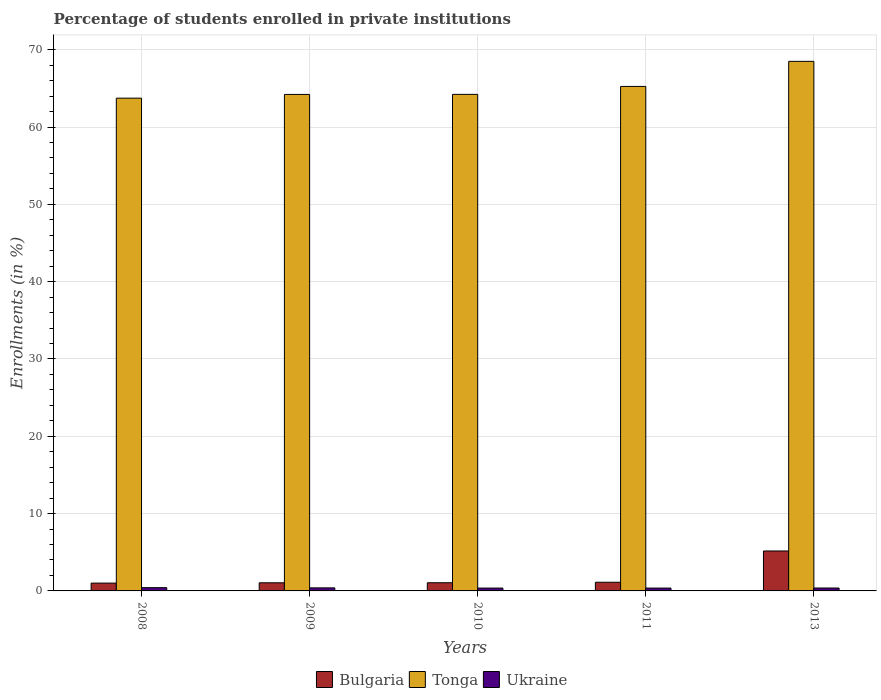How many different coloured bars are there?
Ensure brevity in your answer.  3. Are the number of bars per tick equal to the number of legend labels?
Your response must be concise. Yes. Are the number of bars on each tick of the X-axis equal?
Offer a terse response. Yes. How many bars are there on the 5th tick from the left?
Make the answer very short. 3. What is the percentage of trained teachers in Tonga in 2011?
Give a very brief answer. 65.25. Across all years, what is the maximum percentage of trained teachers in Bulgaria?
Give a very brief answer. 5.17. Across all years, what is the minimum percentage of trained teachers in Tonga?
Your answer should be compact. 63.73. In which year was the percentage of trained teachers in Tonga minimum?
Keep it short and to the point. 2008. What is the total percentage of trained teachers in Ukraine in the graph?
Provide a short and direct response. 1.93. What is the difference between the percentage of trained teachers in Bulgaria in 2009 and that in 2010?
Your response must be concise. -0.01. What is the difference between the percentage of trained teachers in Ukraine in 2011 and the percentage of trained teachers in Tonga in 2008?
Your response must be concise. -63.36. What is the average percentage of trained teachers in Ukraine per year?
Offer a terse response. 0.39. In the year 2011, what is the difference between the percentage of trained teachers in Bulgaria and percentage of trained teachers in Tonga?
Provide a short and direct response. -64.13. In how many years, is the percentage of trained teachers in Bulgaria greater than 28 %?
Keep it short and to the point. 0. What is the ratio of the percentage of trained teachers in Bulgaria in 2009 to that in 2011?
Your response must be concise. 0.94. Is the percentage of trained teachers in Ukraine in 2009 less than that in 2010?
Make the answer very short. No. What is the difference between the highest and the second highest percentage of trained teachers in Tonga?
Provide a short and direct response. 3.24. What is the difference between the highest and the lowest percentage of trained teachers in Ukraine?
Your answer should be very brief. 0.05. Is the sum of the percentage of trained teachers in Tonga in 2010 and 2013 greater than the maximum percentage of trained teachers in Bulgaria across all years?
Make the answer very short. Yes. What does the 2nd bar from the right in 2013 represents?
Offer a terse response. Tonga. Is it the case that in every year, the sum of the percentage of trained teachers in Tonga and percentage of trained teachers in Bulgaria is greater than the percentage of trained teachers in Ukraine?
Keep it short and to the point. Yes. How many years are there in the graph?
Provide a succinct answer. 5. What is the difference between two consecutive major ticks on the Y-axis?
Make the answer very short. 10. Does the graph contain grids?
Keep it short and to the point. Yes. Where does the legend appear in the graph?
Ensure brevity in your answer.  Bottom center. How are the legend labels stacked?
Your response must be concise. Horizontal. What is the title of the graph?
Offer a terse response. Percentage of students enrolled in private institutions. What is the label or title of the X-axis?
Your answer should be very brief. Years. What is the label or title of the Y-axis?
Offer a terse response. Enrollments (in %). What is the Enrollments (in %) of Bulgaria in 2008?
Make the answer very short. 1.01. What is the Enrollments (in %) of Tonga in 2008?
Your answer should be very brief. 63.73. What is the Enrollments (in %) of Ukraine in 2008?
Provide a short and direct response. 0.42. What is the Enrollments (in %) of Bulgaria in 2009?
Ensure brevity in your answer.  1.05. What is the Enrollments (in %) in Tonga in 2009?
Your answer should be compact. 64.21. What is the Enrollments (in %) in Ukraine in 2009?
Offer a terse response. 0.39. What is the Enrollments (in %) of Bulgaria in 2010?
Offer a very short reply. 1.06. What is the Enrollments (in %) of Tonga in 2010?
Make the answer very short. 64.22. What is the Enrollments (in %) of Ukraine in 2010?
Offer a very short reply. 0.37. What is the Enrollments (in %) in Bulgaria in 2011?
Offer a terse response. 1.12. What is the Enrollments (in %) of Tonga in 2011?
Ensure brevity in your answer.  65.25. What is the Enrollments (in %) in Ukraine in 2011?
Your answer should be very brief. 0.37. What is the Enrollments (in %) of Bulgaria in 2013?
Give a very brief answer. 5.17. What is the Enrollments (in %) of Tonga in 2013?
Offer a very short reply. 68.49. What is the Enrollments (in %) of Ukraine in 2013?
Make the answer very short. 0.38. Across all years, what is the maximum Enrollments (in %) in Bulgaria?
Offer a very short reply. 5.17. Across all years, what is the maximum Enrollments (in %) in Tonga?
Offer a terse response. 68.49. Across all years, what is the maximum Enrollments (in %) in Ukraine?
Make the answer very short. 0.42. Across all years, what is the minimum Enrollments (in %) of Bulgaria?
Ensure brevity in your answer.  1.01. Across all years, what is the minimum Enrollments (in %) in Tonga?
Provide a short and direct response. 63.73. Across all years, what is the minimum Enrollments (in %) in Ukraine?
Your answer should be compact. 0.37. What is the total Enrollments (in %) in Bulgaria in the graph?
Make the answer very short. 9.41. What is the total Enrollments (in %) in Tonga in the graph?
Your answer should be very brief. 325.9. What is the total Enrollments (in %) of Ukraine in the graph?
Make the answer very short. 1.93. What is the difference between the Enrollments (in %) in Bulgaria in 2008 and that in 2009?
Offer a terse response. -0.04. What is the difference between the Enrollments (in %) of Tonga in 2008 and that in 2009?
Your answer should be compact. -0.48. What is the difference between the Enrollments (in %) of Ukraine in 2008 and that in 2009?
Provide a short and direct response. 0.03. What is the difference between the Enrollments (in %) of Bulgaria in 2008 and that in 2010?
Keep it short and to the point. -0.05. What is the difference between the Enrollments (in %) of Tonga in 2008 and that in 2010?
Keep it short and to the point. -0.49. What is the difference between the Enrollments (in %) of Ukraine in 2008 and that in 2010?
Your response must be concise. 0.05. What is the difference between the Enrollments (in %) in Bulgaria in 2008 and that in 2011?
Provide a short and direct response. -0.11. What is the difference between the Enrollments (in %) in Tonga in 2008 and that in 2011?
Give a very brief answer. -1.52. What is the difference between the Enrollments (in %) in Ukraine in 2008 and that in 2011?
Keep it short and to the point. 0.05. What is the difference between the Enrollments (in %) of Bulgaria in 2008 and that in 2013?
Provide a short and direct response. -4.15. What is the difference between the Enrollments (in %) in Tonga in 2008 and that in 2013?
Keep it short and to the point. -4.76. What is the difference between the Enrollments (in %) in Ukraine in 2008 and that in 2013?
Offer a very short reply. 0.04. What is the difference between the Enrollments (in %) of Bulgaria in 2009 and that in 2010?
Offer a terse response. -0.01. What is the difference between the Enrollments (in %) in Tonga in 2009 and that in 2010?
Offer a terse response. -0.01. What is the difference between the Enrollments (in %) of Ukraine in 2009 and that in 2010?
Make the answer very short. 0.03. What is the difference between the Enrollments (in %) of Bulgaria in 2009 and that in 2011?
Your response must be concise. -0.07. What is the difference between the Enrollments (in %) in Tonga in 2009 and that in 2011?
Provide a succinct answer. -1.03. What is the difference between the Enrollments (in %) of Ukraine in 2009 and that in 2011?
Your response must be concise. 0.03. What is the difference between the Enrollments (in %) of Bulgaria in 2009 and that in 2013?
Your answer should be compact. -4.12. What is the difference between the Enrollments (in %) in Tonga in 2009 and that in 2013?
Provide a short and direct response. -4.28. What is the difference between the Enrollments (in %) of Ukraine in 2009 and that in 2013?
Your response must be concise. 0.02. What is the difference between the Enrollments (in %) in Bulgaria in 2010 and that in 2011?
Your answer should be very brief. -0.06. What is the difference between the Enrollments (in %) of Tonga in 2010 and that in 2011?
Offer a terse response. -1.03. What is the difference between the Enrollments (in %) in Ukraine in 2010 and that in 2011?
Provide a succinct answer. 0. What is the difference between the Enrollments (in %) in Bulgaria in 2010 and that in 2013?
Provide a short and direct response. -4.11. What is the difference between the Enrollments (in %) of Tonga in 2010 and that in 2013?
Offer a terse response. -4.27. What is the difference between the Enrollments (in %) of Ukraine in 2010 and that in 2013?
Offer a terse response. -0.01. What is the difference between the Enrollments (in %) of Bulgaria in 2011 and that in 2013?
Your answer should be very brief. -4.05. What is the difference between the Enrollments (in %) in Tonga in 2011 and that in 2013?
Make the answer very short. -3.24. What is the difference between the Enrollments (in %) in Ukraine in 2011 and that in 2013?
Provide a succinct answer. -0.01. What is the difference between the Enrollments (in %) in Bulgaria in 2008 and the Enrollments (in %) in Tonga in 2009?
Offer a very short reply. -63.2. What is the difference between the Enrollments (in %) in Bulgaria in 2008 and the Enrollments (in %) in Ukraine in 2009?
Keep it short and to the point. 0.62. What is the difference between the Enrollments (in %) in Tonga in 2008 and the Enrollments (in %) in Ukraine in 2009?
Ensure brevity in your answer.  63.34. What is the difference between the Enrollments (in %) in Bulgaria in 2008 and the Enrollments (in %) in Tonga in 2010?
Provide a short and direct response. -63.21. What is the difference between the Enrollments (in %) of Bulgaria in 2008 and the Enrollments (in %) of Ukraine in 2010?
Offer a very short reply. 0.64. What is the difference between the Enrollments (in %) in Tonga in 2008 and the Enrollments (in %) in Ukraine in 2010?
Offer a very short reply. 63.36. What is the difference between the Enrollments (in %) in Bulgaria in 2008 and the Enrollments (in %) in Tonga in 2011?
Keep it short and to the point. -64.24. What is the difference between the Enrollments (in %) of Bulgaria in 2008 and the Enrollments (in %) of Ukraine in 2011?
Ensure brevity in your answer.  0.64. What is the difference between the Enrollments (in %) of Tonga in 2008 and the Enrollments (in %) of Ukraine in 2011?
Ensure brevity in your answer.  63.36. What is the difference between the Enrollments (in %) of Bulgaria in 2008 and the Enrollments (in %) of Tonga in 2013?
Ensure brevity in your answer.  -67.48. What is the difference between the Enrollments (in %) of Bulgaria in 2008 and the Enrollments (in %) of Ukraine in 2013?
Provide a short and direct response. 0.63. What is the difference between the Enrollments (in %) of Tonga in 2008 and the Enrollments (in %) of Ukraine in 2013?
Give a very brief answer. 63.35. What is the difference between the Enrollments (in %) of Bulgaria in 2009 and the Enrollments (in %) of Tonga in 2010?
Offer a terse response. -63.17. What is the difference between the Enrollments (in %) of Bulgaria in 2009 and the Enrollments (in %) of Ukraine in 2010?
Offer a very short reply. 0.68. What is the difference between the Enrollments (in %) of Tonga in 2009 and the Enrollments (in %) of Ukraine in 2010?
Your answer should be very brief. 63.84. What is the difference between the Enrollments (in %) in Bulgaria in 2009 and the Enrollments (in %) in Tonga in 2011?
Offer a very short reply. -64.2. What is the difference between the Enrollments (in %) in Bulgaria in 2009 and the Enrollments (in %) in Ukraine in 2011?
Your answer should be very brief. 0.68. What is the difference between the Enrollments (in %) in Tonga in 2009 and the Enrollments (in %) in Ukraine in 2011?
Give a very brief answer. 63.85. What is the difference between the Enrollments (in %) of Bulgaria in 2009 and the Enrollments (in %) of Tonga in 2013?
Your answer should be very brief. -67.44. What is the difference between the Enrollments (in %) of Bulgaria in 2009 and the Enrollments (in %) of Ukraine in 2013?
Ensure brevity in your answer.  0.67. What is the difference between the Enrollments (in %) in Tonga in 2009 and the Enrollments (in %) in Ukraine in 2013?
Your response must be concise. 63.84. What is the difference between the Enrollments (in %) in Bulgaria in 2010 and the Enrollments (in %) in Tonga in 2011?
Your answer should be compact. -64.19. What is the difference between the Enrollments (in %) in Bulgaria in 2010 and the Enrollments (in %) in Ukraine in 2011?
Give a very brief answer. 0.69. What is the difference between the Enrollments (in %) of Tonga in 2010 and the Enrollments (in %) of Ukraine in 2011?
Your response must be concise. 63.85. What is the difference between the Enrollments (in %) of Bulgaria in 2010 and the Enrollments (in %) of Tonga in 2013?
Your answer should be very brief. -67.43. What is the difference between the Enrollments (in %) in Bulgaria in 2010 and the Enrollments (in %) in Ukraine in 2013?
Give a very brief answer. 0.68. What is the difference between the Enrollments (in %) of Tonga in 2010 and the Enrollments (in %) of Ukraine in 2013?
Provide a short and direct response. 63.84. What is the difference between the Enrollments (in %) in Bulgaria in 2011 and the Enrollments (in %) in Tonga in 2013?
Give a very brief answer. -67.37. What is the difference between the Enrollments (in %) of Bulgaria in 2011 and the Enrollments (in %) of Ukraine in 2013?
Offer a very short reply. 0.74. What is the difference between the Enrollments (in %) in Tonga in 2011 and the Enrollments (in %) in Ukraine in 2013?
Your answer should be compact. 64.87. What is the average Enrollments (in %) in Bulgaria per year?
Ensure brevity in your answer.  1.88. What is the average Enrollments (in %) of Tonga per year?
Your response must be concise. 65.18. What is the average Enrollments (in %) in Ukraine per year?
Make the answer very short. 0.39. In the year 2008, what is the difference between the Enrollments (in %) of Bulgaria and Enrollments (in %) of Tonga?
Your response must be concise. -62.72. In the year 2008, what is the difference between the Enrollments (in %) of Bulgaria and Enrollments (in %) of Ukraine?
Provide a succinct answer. 0.59. In the year 2008, what is the difference between the Enrollments (in %) of Tonga and Enrollments (in %) of Ukraine?
Provide a short and direct response. 63.31. In the year 2009, what is the difference between the Enrollments (in %) in Bulgaria and Enrollments (in %) in Tonga?
Your response must be concise. -63.16. In the year 2009, what is the difference between the Enrollments (in %) in Bulgaria and Enrollments (in %) in Ukraine?
Your response must be concise. 0.66. In the year 2009, what is the difference between the Enrollments (in %) of Tonga and Enrollments (in %) of Ukraine?
Provide a short and direct response. 63.82. In the year 2010, what is the difference between the Enrollments (in %) in Bulgaria and Enrollments (in %) in Tonga?
Provide a short and direct response. -63.16. In the year 2010, what is the difference between the Enrollments (in %) in Bulgaria and Enrollments (in %) in Ukraine?
Your response must be concise. 0.69. In the year 2010, what is the difference between the Enrollments (in %) of Tonga and Enrollments (in %) of Ukraine?
Offer a very short reply. 63.85. In the year 2011, what is the difference between the Enrollments (in %) in Bulgaria and Enrollments (in %) in Tonga?
Your response must be concise. -64.13. In the year 2011, what is the difference between the Enrollments (in %) in Bulgaria and Enrollments (in %) in Ukraine?
Offer a very short reply. 0.75. In the year 2011, what is the difference between the Enrollments (in %) of Tonga and Enrollments (in %) of Ukraine?
Give a very brief answer. 64.88. In the year 2013, what is the difference between the Enrollments (in %) in Bulgaria and Enrollments (in %) in Tonga?
Keep it short and to the point. -63.32. In the year 2013, what is the difference between the Enrollments (in %) of Bulgaria and Enrollments (in %) of Ukraine?
Your response must be concise. 4.79. In the year 2013, what is the difference between the Enrollments (in %) of Tonga and Enrollments (in %) of Ukraine?
Offer a terse response. 68.11. What is the ratio of the Enrollments (in %) in Bulgaria in 2008 to that in 2009?
Provide a short and direct response. 0.96. What is the ratio of the Enrollments (in %) in Ukraine in 2008 to that in 2009?
Your answer should be very brief. 1.07. What is the ratio of the Enrollments (in %) of Bulgaria in 2008 to that in 2010?
Your response must be concise. 0.96. What is the ratio of the Enrollments (in %) in Tonga in 2008 to that in 2010?
Offer a terse response. 0.99. What is the ratio of the Enrollments (in %) in Ukraine in 2008 to that in 2010?
Ensure brevity in your answer.  1.14. What is the ratio of the Enrollments (in %) in Bulgaria in 2008 to that in 2011?
Keep it short and to the point. 0.9. What is the ratio of the Enrollments (in %) in Tonga in 2008 to that in 2011?
Provide a succinct answer. 0.98. What is the ratio of the Enrollments (in %) in Ukraine in 2008 to that in 2011?
Give a very brief answer. 1.15. What is the ratio of the Enrollments (in %) in Bulgaria in 2008 to that in 2013?
Provide a short and direct response. 0.2. What is the ratio of the Enrollments (in %) in Tonga in 2008 to that in 2013?
Your answer should be very brief. 0.93. What is the ratio of the Enrollments (in %) in Ukraine in 2008 to that in 2013?
Provide a short and direct response. 1.12. What is the ratio of the Enrollments (in %) in Tonga in 2009 to that in 2010?
Keep it short and to the point. 1. What is the ratio of the Enrollments (in %) in Ukraine in 2009 to that in 2010?
Your response must be concise. 1.07. What is the ratio of the Enrollments (in %) in Bulgaria in 2009 to that in 2011?
Make the answer very short. 0.94. What is the ratio of the Enrollments (in %) of Tonga in 2009 to that in 2011?
Offer a very short reply. 0.98. What is the ratio of the Enrollments (in %) of Ukraine in 2009 to that in 2011?
Your response must be concise. 1.07. What is the ratio of the Enrollments (in %) of Bulgaria in 2009 to that in 2013?
Your response must be concise. 0.2. What is the ratio of the Enrollments (in %) of Tonga in 2009 to that in 2013?
Provide a succinct answer. 0.94. What is the ratio of the Enrollments (in %) of Ukraine in 2009 to that in 2013?
Give a very brief answer. 1.05. What is the ratio of the Enrollments (in %) in Bulgaria in 2010 to that in 2011?
Offer a very short reply. 0.94. What is the ratio of the Enrollments (in %) of Tonga in 2010 to that in 2011?
Ensure brevity in your answer.  0.98. What is the ratio of the Enrollments (in %) of Bulgaria in 2010 to that in 2013?
Provide a short and direct response. 0.2. What is the ratio of the Enrollments (in %) of Tonga in 2010 to that in 2013?
Offer a very short reply. 0.94. What is the ratio of the Enrollments (in %) of Ukraine in 2010 to that in 2013?
Ensure brevity in your answer.  0.98. What is the ratio of the Enrollments (in %) in Bulgaria in 2011 to that in 2013?
Ensure brevity in your answer.  0.22. What is the ratio of the Enrollments (in %) of Tonga in 2011 to that in 2013?
Offer a very short reply. 0.95. What is the ratio of the Enrollments (in %) of Ukraine in 2011 to that in 2013?
Offer a terse response. 0.98. What is the difference between the highest and the second highest Enrollments (in %) in Bulgaria?
Ensure brevity in your answer.  4.05. What is the difference between the highest and the second highest Enrollments (in %) of Tonga?
Your answer should be compact. 3.24. What is the difference between the highest and the second highest Enrollments (in %) in Ukraine?
Offer a terse response. 0.03. What is the difference between the highest and the lowest Enrollments (in %) of Bulgaria?
Provide a short and direct response. 4.15. What is the difference between the highest and the lowest Enrollments (in %) of Tonga?
Ensure brevity in your answer.  4.76. What is the difference between the highest and the lowest Enrollments (in %) in Ukraine?
Provide a short and direct response. 0.05. 